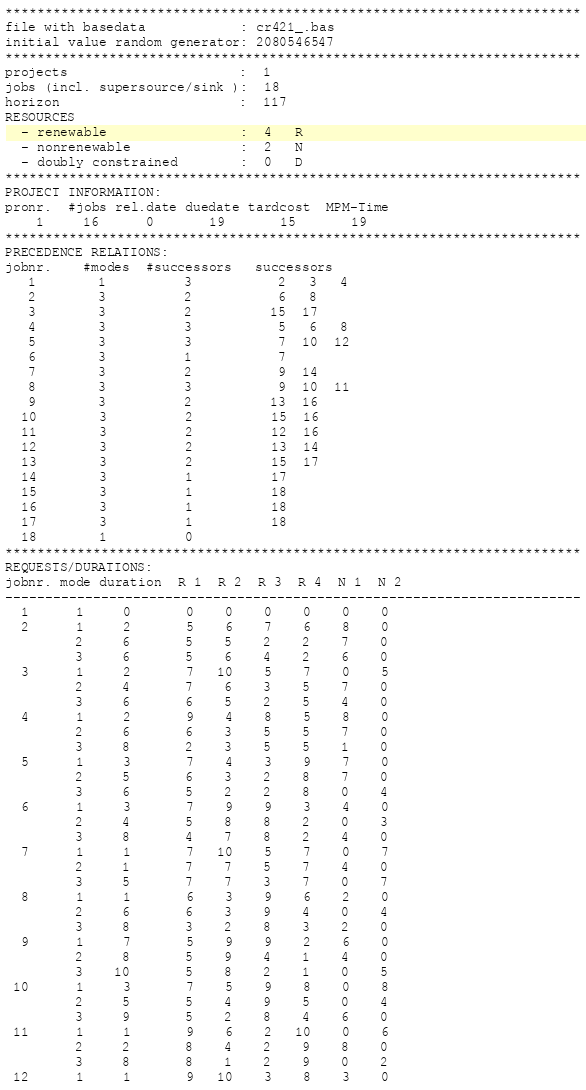<code> <loc_0><loc_0><loc_500><loc_500><_ObjectiveC_>************************************************************************
file with basedata            : cr421_.bas
initial value random generator: 2080546547
************************************************************************
projects                      :  1
jobs (incl. supersource/sink ):  18
horizon                       :  117
RESOURCES
  - renewable                 :  4   R
  - nonrenewable              :  2   N
  - doubly constrained        :  0   D
************************************************************************
PROJECT INFORMATION:
pronr.  #jobs rel.date duedate tardcost  MPM-Time
    1     16      0       19       15       19
************************************************************************
PRECEDENCE RELATIONS:
jobnr.    #modes  #successors   successors
   1        1          3           2   3   4
   2        3          2           6   8
   3        3          2          15  17
   4        3          3           5   6   8
   5        3          3           7  10  12
   6        3          1           7
   7        3          2           9  14
   8        3          3           9  10  11
   9        3          2          13  16
  10        3          2          15  16
  11        3          2          12  16
  12        3          2          13  14
  13        3          2          15  17
  14        3          1          17
  15        3          1          18
  16        3          1          18
  17        3          1          18
  18        1          0        
************************************************************************
REQUESTS/DURATIONS:
jobnr. mode duration  R 1  R 2  R 3  R 4  N 1  N 2
------------------------------------------------------------------------
  1      1     0       0    0    0    0    0    0
  2      1     2       5    6    7    6    8    0
         2     6       5    5    2    2    7    0
         3     6       5    6    4    2    6    0
  3      1     2       7   10    5    7    0    5
         2     4       7    6    3    5    7    0
         3     6       6    5    2    5    4    0
  4      1     2       9    4    8    5    8    0
         2     6       6    3    5    5    7    0
         3     8       2    3    5    5    1    0
  5      1     3       7    4    3    9    7    0
         2     5       6    3    2    8    7    0
         3     6       5    2    2    8    0    4
  6      1     3       7    9    9    3    4    0
         2     4       5    8    8    2    0    3
         3     8       4    7    8    2    4    0
  7      1     1       7   10    5    7    0    7
         2     1       7    7    5    7    4    0
         3     5       7    7    3    7    0    7
  8      1     1       6    3    9    6    2    0
         2     6       6    3    9    4    0    4
         3     8       3    2    8    3    2    0
  9      1     7       5    9    9    2    6    0
         2     8       5    9    4    1    4    0
         3    10       5    8    2    1    0    5
 10      1     3       7    5    9    8    0    8
         2     5       5    4    9    5    0    4
         3     9       5    2    8    4    6    0
 11      1     1       9    6    2   10    0    6
         2     2       8    4    2    9    8    0
         3     8       8    1    2    9    0    2
 12      1     1       9   10    3    8    3    0</code> 